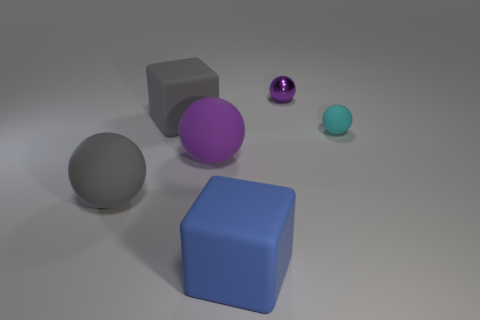Subtract all red blocks. Subtract all gray balls. How many blocks are left? 2 Add 3 large purple rubber objects. How many objects exist? 9 Subtract all spheres. How many objects are left? 2 Add 6 large purple balls. How many large purple balls are left? 7 Add 2 large red shiny objects. How many large red shiny objects exist? 2 Subtract 0 brown spheres. How many objects are left? 6 Subtract all small purple metal balls. Subtract all balls. How many objects are left? 1 